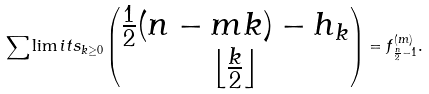Convert formula to latex. <formula><loc_0><loc_0><loc_500><loc_500>\sum \lim i t s _ { k \geq 0 } \begin{pmatrix} \frac { 1 } { 2 } ( n - m k ) - h _ { k } \\ \left \lfloor \frac { k } { 2 } \right \rfloor \end{pmatrix} = f ^ { ( m ) } _ { \frac { n } { 2 } - 1 } .</formula> 